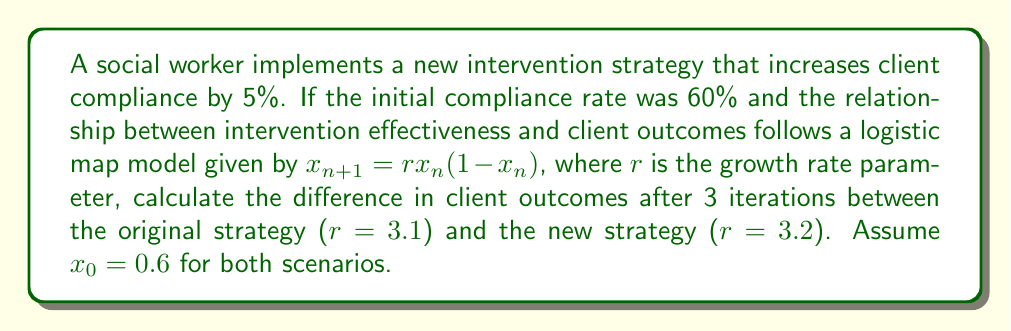Show me your answer to this math problem. Let's approach this step-by-step using the logistic map model:

1) For the original strategy ($r=3.1$, $x_0=0.6$):

   Iteration 1: $x_1 = 3.1 * 0.6 * (1-0.6) = 0.744$
   Iteration 2: $x_2 = 3.1 * 0.744 * (1-0.744) = 0.590016$
   Iteration 3: $x_3 = 3.1 * 0.590016 * (1-0.590016) = 0.746397$

2) For the new strategy ($r=3.2$, $x_0=0.6$):

   Iteration 1: $x_1 = 3.2 * 0.6 * (1-0.6) = 0.768$
   Iteration 2: $x_2 = 3.2 * 0.768 * (1-0.768) = 0.570163$
   Iteration 3: $x_3 = 3.2 * 0.570163 * (1-0.570163) = 0.784841$

3) Calculate the difference:

   Difference = New strategy outcome - Original strategy outcome
               = 0.784841 - 0.746397
               = 0.038444

4) Convert to percentage:
   
   Percentage difference = 0.038444 * 100% = 3.8444%

This demonstrates the butterfly effect in social work interventions, where a small initial change (5% increase in compliance) leads to a noticeable difference in outcomes after just a few iterations.
Answer: 3.8444% 